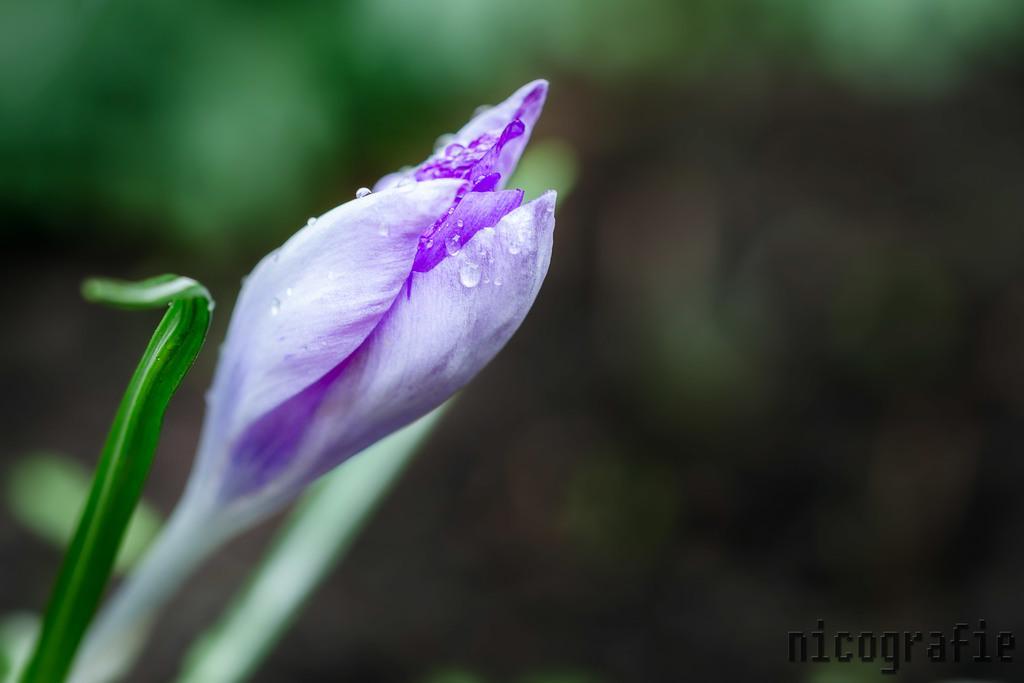Describe this image in one or two sentences. On the background of the picture it's very blur. In Front of the picture we can see a purple colour flower bud. We can also see few droplets of water. 